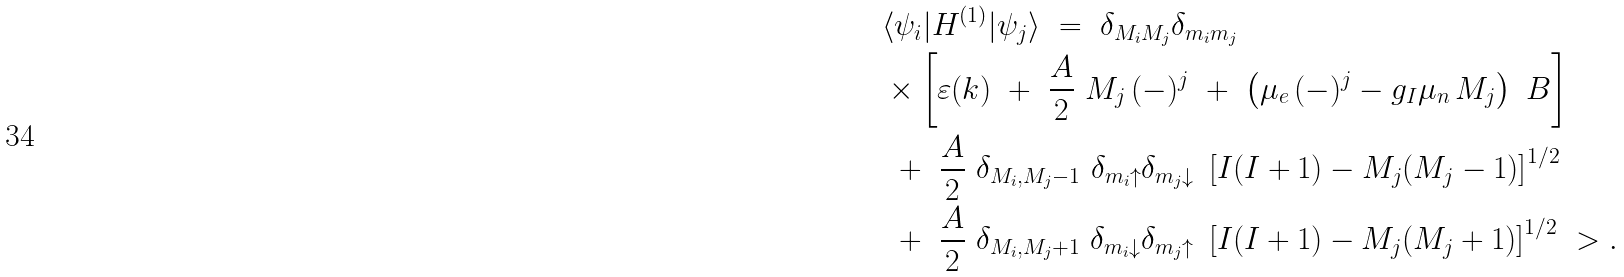<formula> <loc_0><loc_0><loc_500><loc_500>& \langle \psi _ { i } | H ^ { ( 1 ) } | \psi _ { j } \rangle \ = \ \delta _ { M _ { i } M _ { j } } \delta _ { m _ { i } m _ { j } } \ \\ & \times \left [ \varepsilon ( k ) \ + \ \frac { A } { 2 } \ M _ { j } \, ( - ) ^ { j } \ + \ \left ( \mu _ { e } \, ( - ) ^ { j } - g _ { I } \mu _ { n } \, M _ { j } \right ) \ B \right ] \\ & \ + \ \frac { A } { 2 } \ \delta _ { M _ { i } , M _ { j } - 1 } \ \delta _ { m _ { i } \uparrow } \delta _ { m _ { j } \downarrow } \ \left [ I ( I + 1 ) - M _ { j } ( M _ { j } - 1 ) \right ] ^ { 1 / 2 } \\ & \ + \ \frac { A } { 2 } \ \delta _ { M _ { i } , M _ { j } + 1 } \ \delta _ { m _ { i } \downarrow } \delta _ { m _ { j } \uparrow } \ \left [ I ( I + 1 ) - M _ { j } ( M _ { j } + 1 ) \right ] ^ { 1 / 2 } \ > .</formula> 